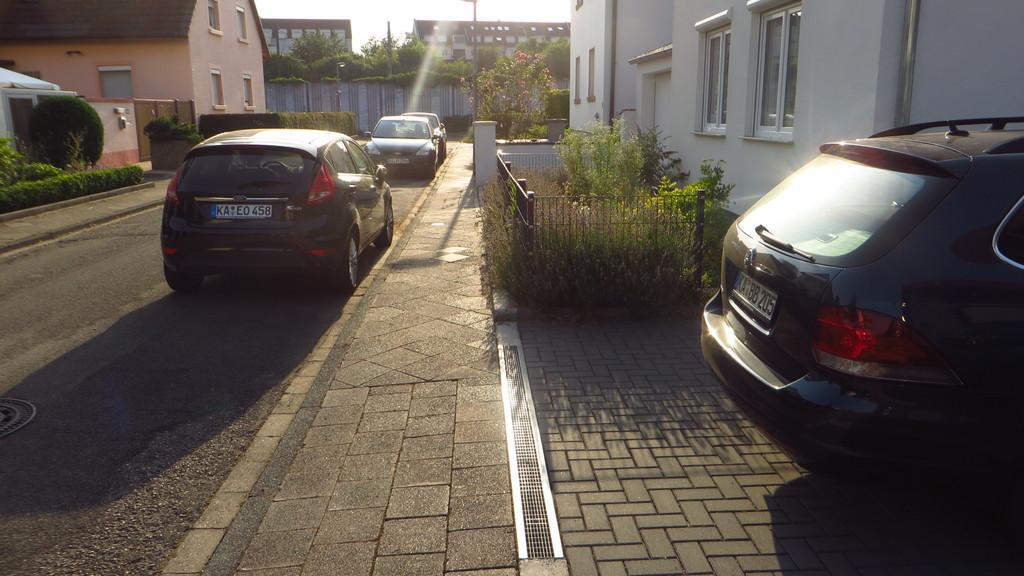Please provide a concise description of this image. On the right side image there is a car and also there are houses, plants with mesh fencing. And on the left side of the image on the road there are cars. And also there are buildings, fencing walls, trees, poles and also there are bushes. 